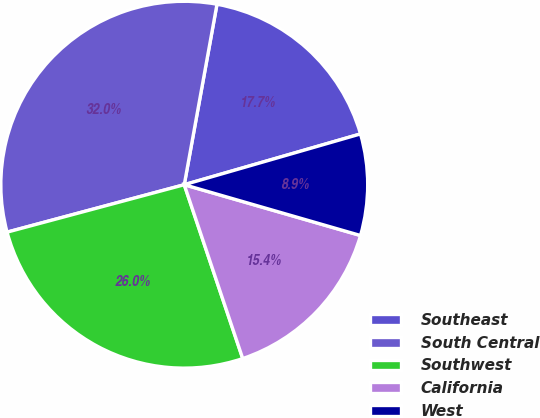<chart> <loc_0><loc_0><loc_500><loc_500><pie_chart><fcel>Southeast<fcel>South Central<fcel>Southwest<fcel>California<fcel>West<nl><fcel>17.68%<fcel>32.02%<fcel>26.0%<fcel>15.37%<fcel>8.93%<nl></chart> 